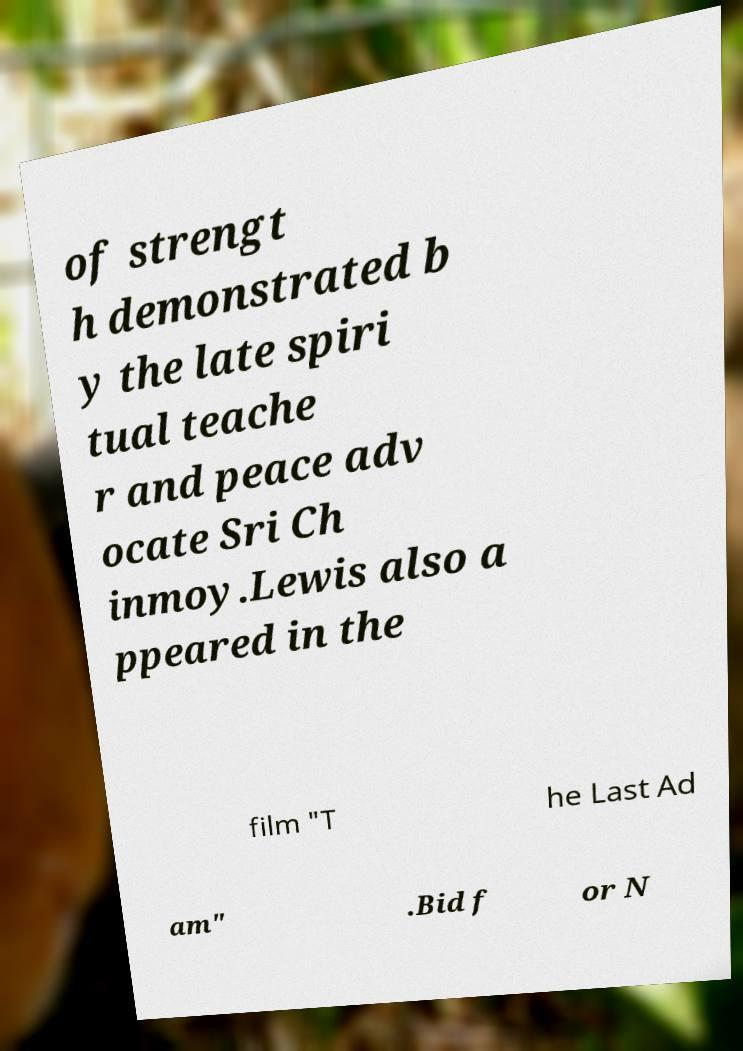For documentation purposes, I need the text within this image transcribed. Could you provide that? of strengt h demonstrated b y the late spiri tual teache r and peace adv ocate Sri Ch inmoy.Lewis also a ppeared in the film "T he Last Ad am" .Bid f or N 